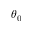<formula> <loc_0><loc_0><loc_500><loc_500>\theta _ { 0 }</formula> 